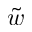Convert formula to latex. <formula><loc_0><loc_0><loc_500><loc_500>\tilde { w }</formula> 